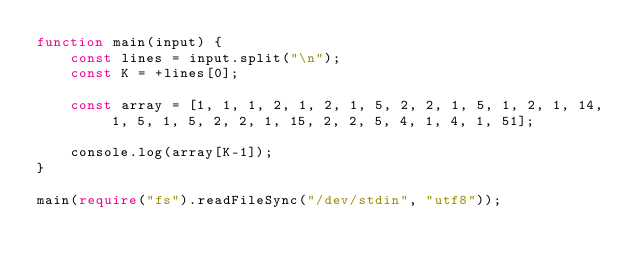<code> <loc_0><loc_0><loc_500><loc_500><_TypeScript_>function main(input) {
    const lines = input.split("\n");
    const K = +lines[0];

    const array = [1, 1, 1, 2, 1, 2, 1, 5, 2, 2, 1, 5, 1, 2, 1, 14, 1, 5, 1, 5, 2, 2, 1, 15, 2, 2, 5, 4, 1, 4, 1, 51];
    
    console.log(array[K-1]);
}

main(require("fs").readFileSync("/dev/stdin", "utf8"));</code> 